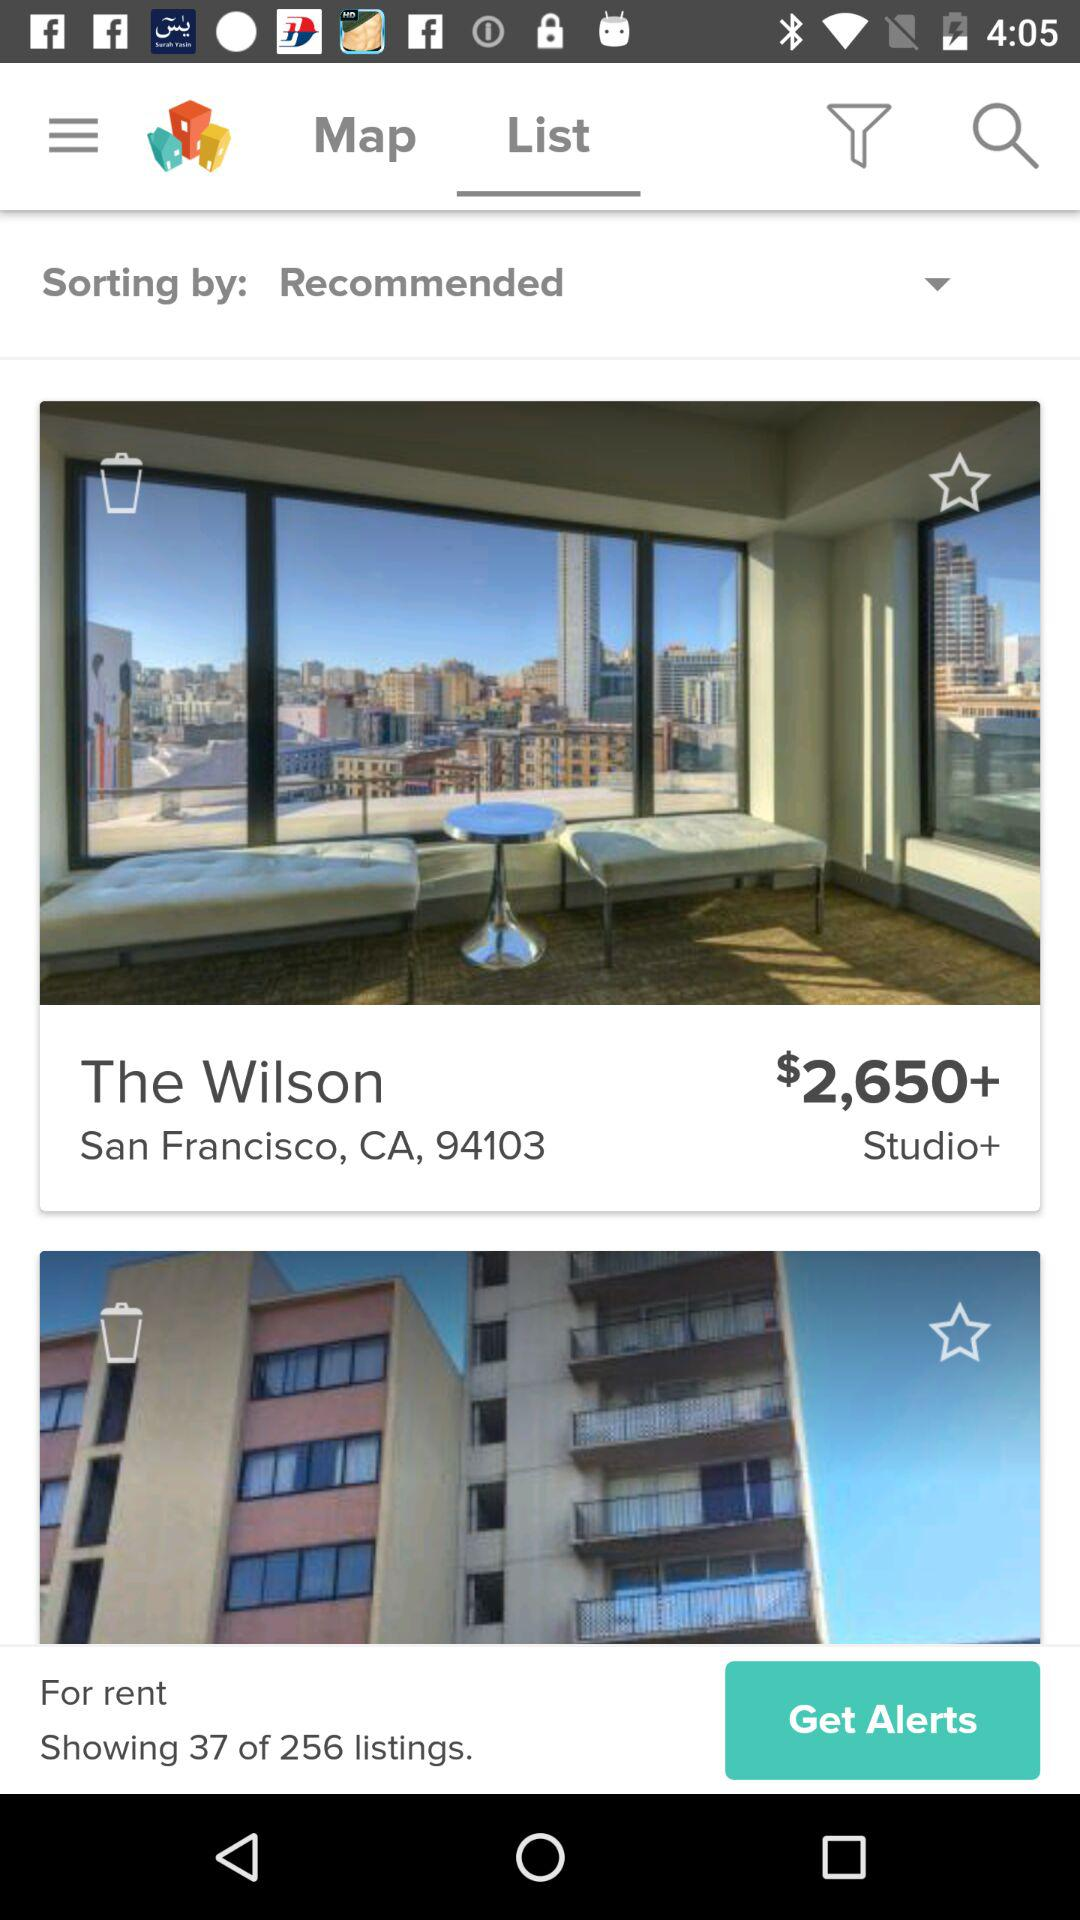What is the total number of listings? The total number of listings is 256. 